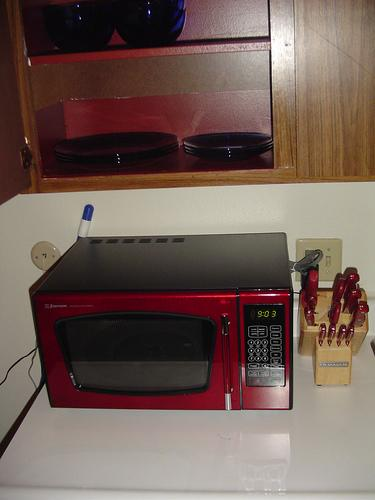Mention the unique feature of the knives in the image and where they are located. The knives have red handles and are placed in a wooden knife block next to the microwave in the kitchen. Identify the main kitchen appliance in the image and describe its color. The main appliance is a red and black microwave sitting on the countertop. Describe the elements surrounding the primary appliance in the image. A red and black microwave is on the countertop, with a wooden shelf above it, a red knife set to the right, and a tan light switch to the left. Explain the setting of the photograph in the context of a domestic environment. This image shows a cozy kitchen setting with a red microwave, a wooden knife block with red knives, and a wooden cabinet holding black plates. Describe the appearance of the microwave's control panel in the image. The microwave features a digital panel with 903 readout, black buttons, and white numbers. List three objects found in the image and their positions relative to the microwave. Wooden knife block to the right, tan light switch to the left, and wooden shelf above the microwave. Provide details about the storage unit present in the image and its contents. A brown wooden kitchen cabinet holds black plates stacked neatly and is located above a wooden shelf. Describe the cutlery set found in the image and where it is placed. There is a set of red-handled knives inside a wooden knife block, placed on the countertop next to the microwave. Mention the colors and position of the light switch and outlet in the image. A tan light switch is to the left of the microwave, and a tan telephone outlet is below the wooden shelf. Briefly mention the primary objects and their colors in the image. There's a bright red microwave, a set of red knives, a wooden knife block, and black plates stacked in a cabinet within the image. 